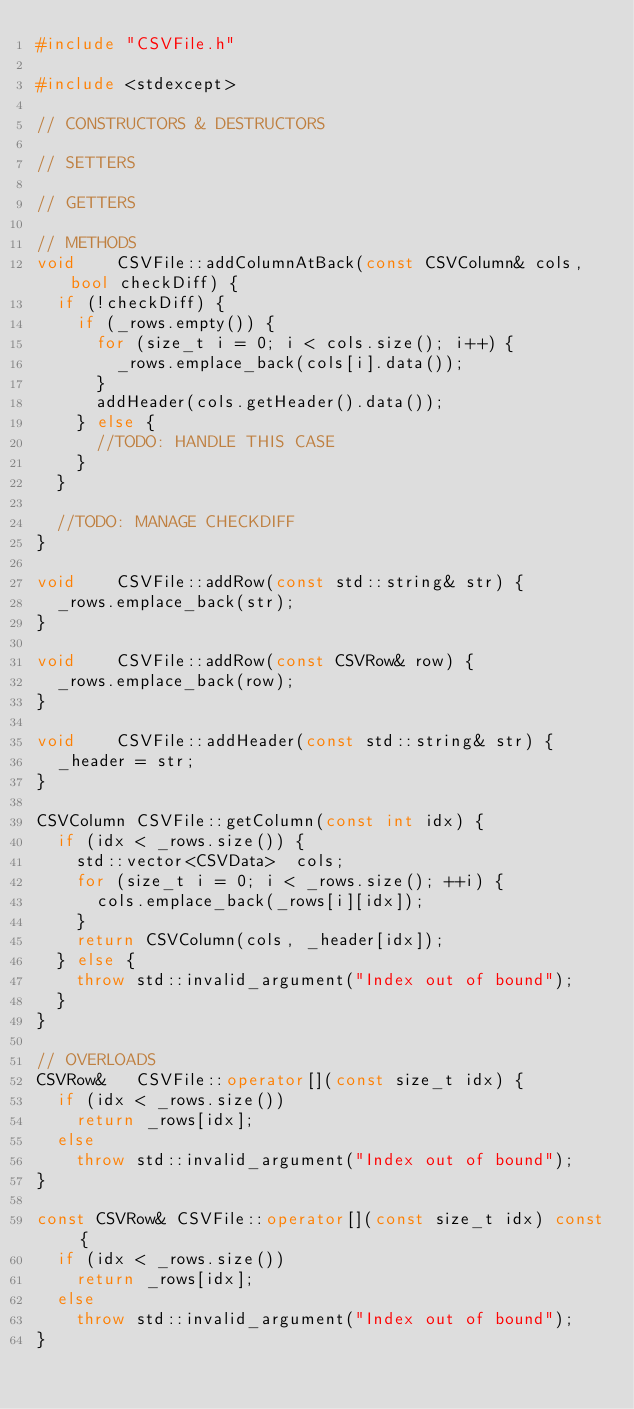<code> <loc_0><loc_0><loc_500><loc_500><_C++_>#include "CSVFile.h"

#include <stdexcept>

// CONSTRUCTORS & DESTRUCTORS

// SETTERS

// GETTERS

// METHODS
void		CSVFile::addColumnAtBack(const CSVColumn& cols, bool checkDiff) {
	if (!checkDiff) {
		if (_rows.empty()) {
			for (size_t i = 0; i < cols.size(); i++) {
				_rows.emplace_back(cols[i].data());
			}
			addHeader(cols.getHeader().data());
		} else {
			//TODO: HANDLE THIS CASE
		}
	}
	
	//TODO: MANAGE CHECKDIFF
}

void		CSVFile::addRow(const std::string& str) {
	_rows.emplace_back(str);
}

void		CSVFile::addRow(const CSVRow& row) {
	_rows.emplace_back(row);
}

void		CSVFile::addHeader(const std::string& str) {
	_header = str;
}

CSVColumn	CSVFile::getColumn(const int idx) {
	if (idx < _rows.size()) {
		std::vector<CSVData>	cols;
		for (size_t i = 0; i < _rows.size(); ++i) {
			cols.emplace_back(_rows[i][idx]);
		}
		return CSVColumn(cols, _header[idx]);
	} else {
		throw std::invalid_argument("Index out of bound");
	}
}
	
// OVERLOADS
CSVRow&		CSVFile::operator[](const size_t idx) {
	if (idx < _rows.size())
		return _rows[idx];
	else
		throw std::invalid_argument("Index out of bound");
}

const CSVRow&	CSVFile::operator[](const size_t idx) const {
	if (idx < _rows.size())
		return _rows[idx];
	else
		throw std::invalid_argument("Index out of bound");
}</code> 